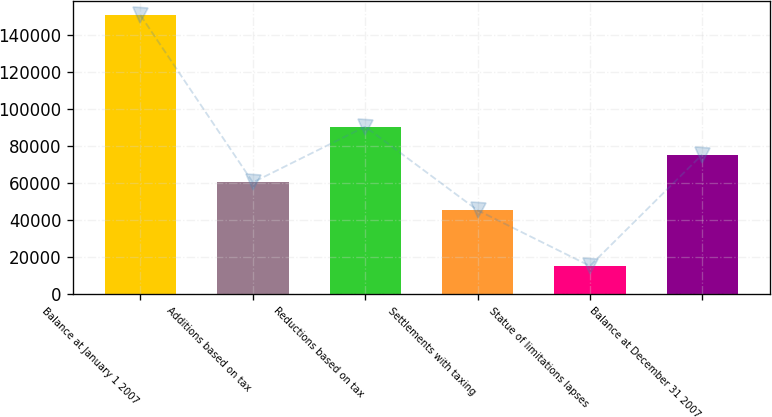<chart> <loc_0><loc_0><loc_500><loc_500><bar_chart><fcel>Balance at January 1 2007<fcel>Additions based on tax<fcel>Reductions based on tax<fcel>Settlements with taxing<fcel>Statue of limitations lapses<fcel>Balance at December 31 2007<nl><fcel>150428<fcel>60252.8<fcel>90311.2<fcel>45223.6<fcel>15165.2<fcel>75282<nl></chart> 